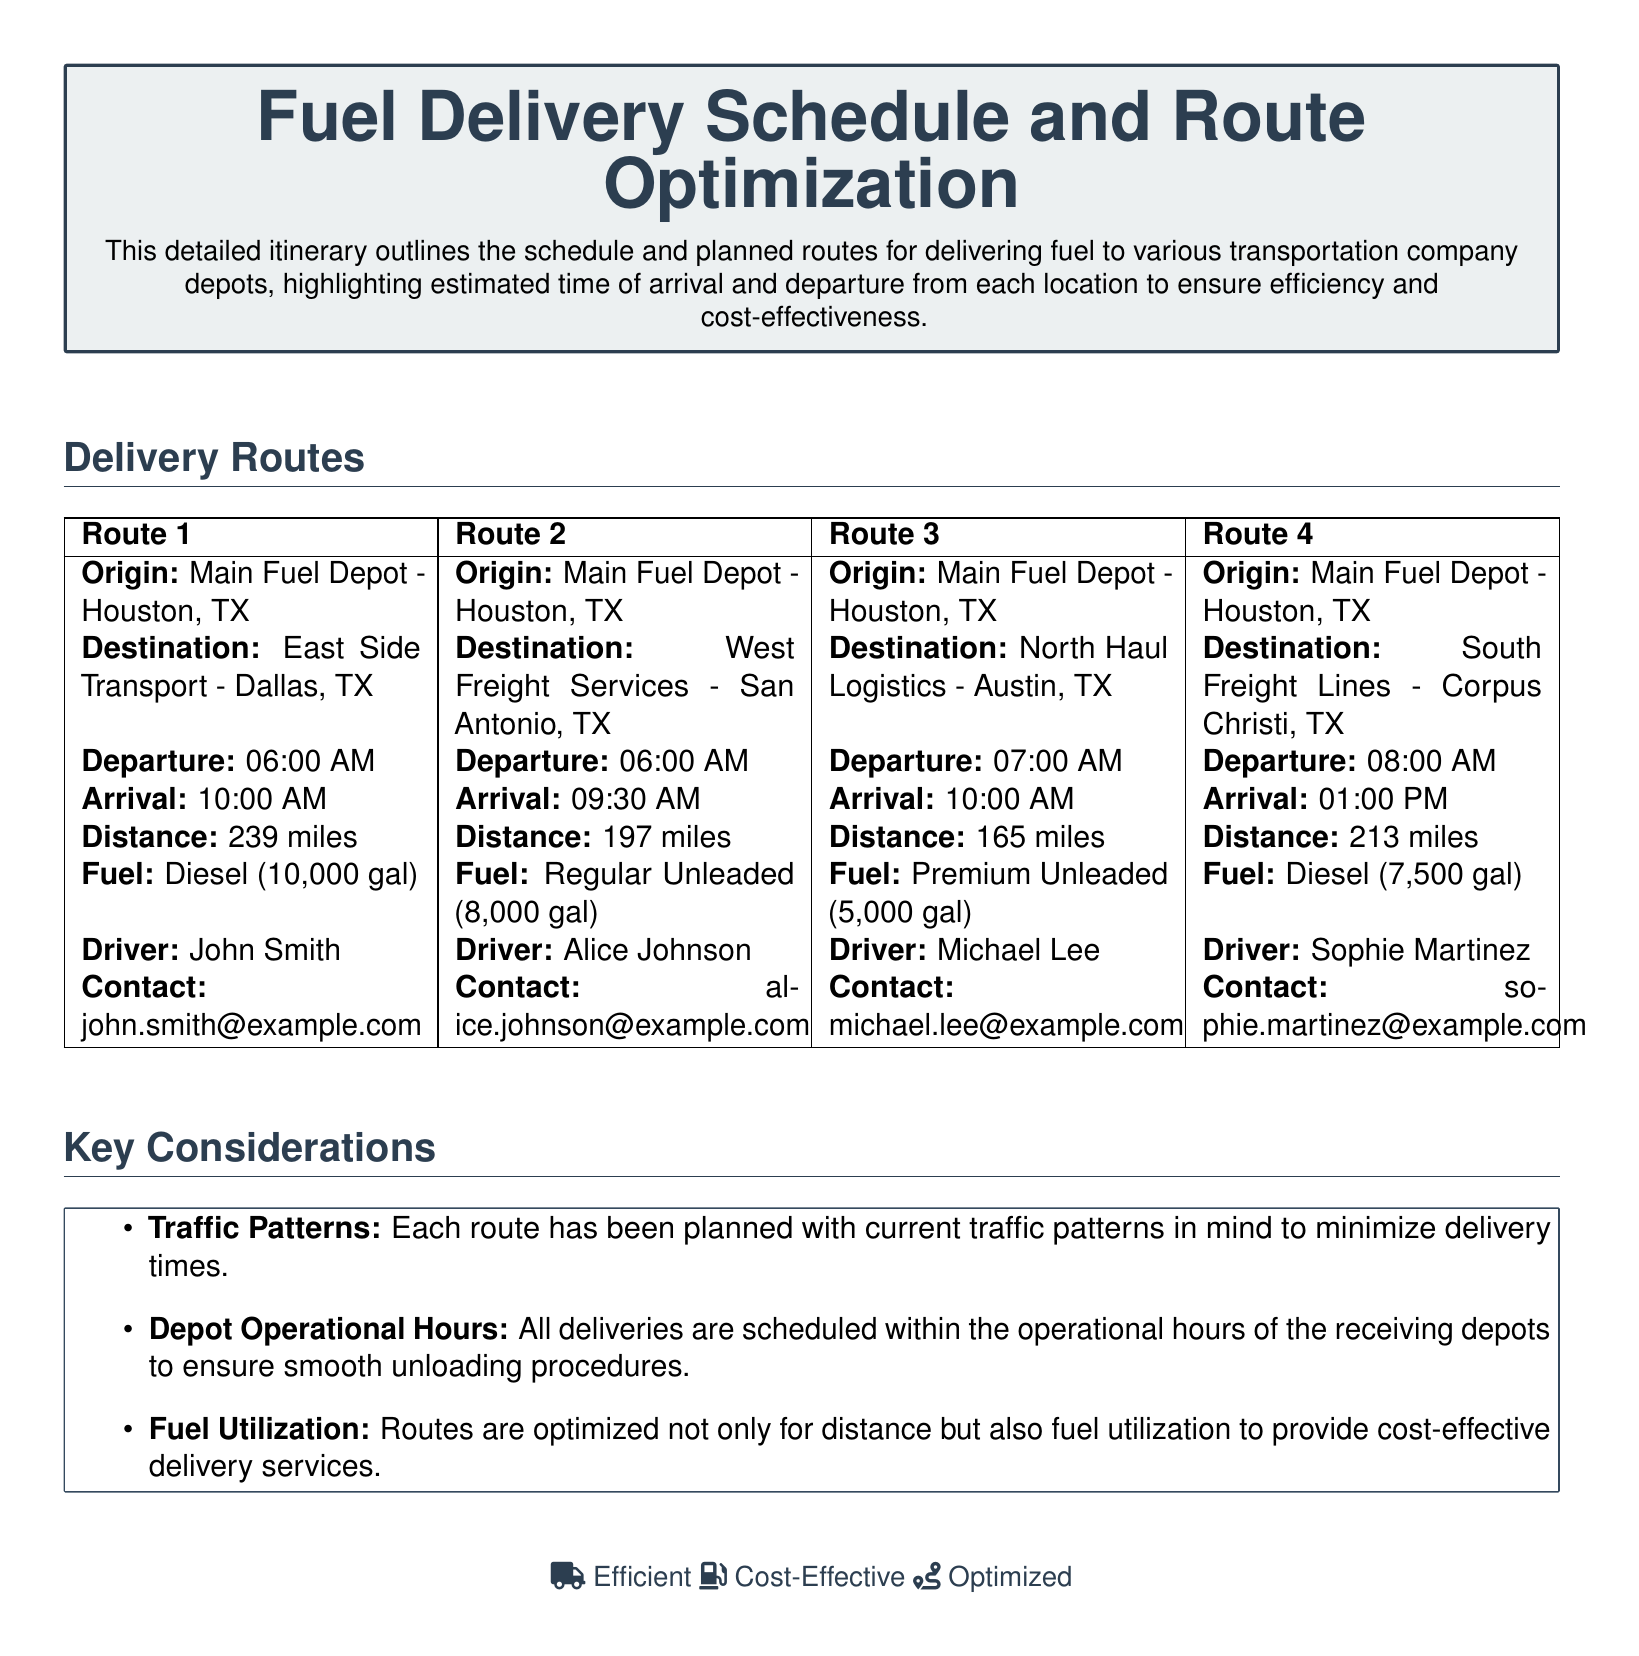What is the origin of Route 1? The origin of Route 1 is Main Fuel Depot - Houston, TX.
Answer: Main Fuel Depot - Houston, TX What is the estimated arrival time for Route 3? The estimated arrival time for Route 3 is provided in the itinerary.
Answer: 10:00 AM How far is the destination for Route 2? The distance for Route 2 is specified in the document, detailing how far it is.
Answer: 197 miles Who is the driver for Route 4? The document specifies the driver assigned to Route 4.
Answer: Sophie Martinez What type of fuel is used for Route 1? The type of fuel for Route 1 is explicitly mentioned in the itinerary.
Answer: Diesel (10,000 gal) Which route has the earliest departure time? By comparing the departure times listed in the document, we can determine which is earliest.
Answer: Route 1 How many gallons of Premium Unleaded fuel are being delivered on Route 3? The amount of fuel for Route 3 is stated clearly in the document.
Answer: 5,000 gal What factors are considered for route optimization? The document lists key factors that were taken into account for route planning.
Answer: Traffic Patterns, Depot Operational Hours, Fuel Utilization What is the main purpose of this document? The main purpose is articulated in the summary section of the document.
Answer: Cost-effective delivery services 